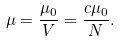Convert formula to latex. <formula><loc_0><loc_0><loc_500><loc_500>\mu = \frac { \mu _ { 0 } } { V } = \frac { c \mu _ { 0 } } { N } .</formula> 